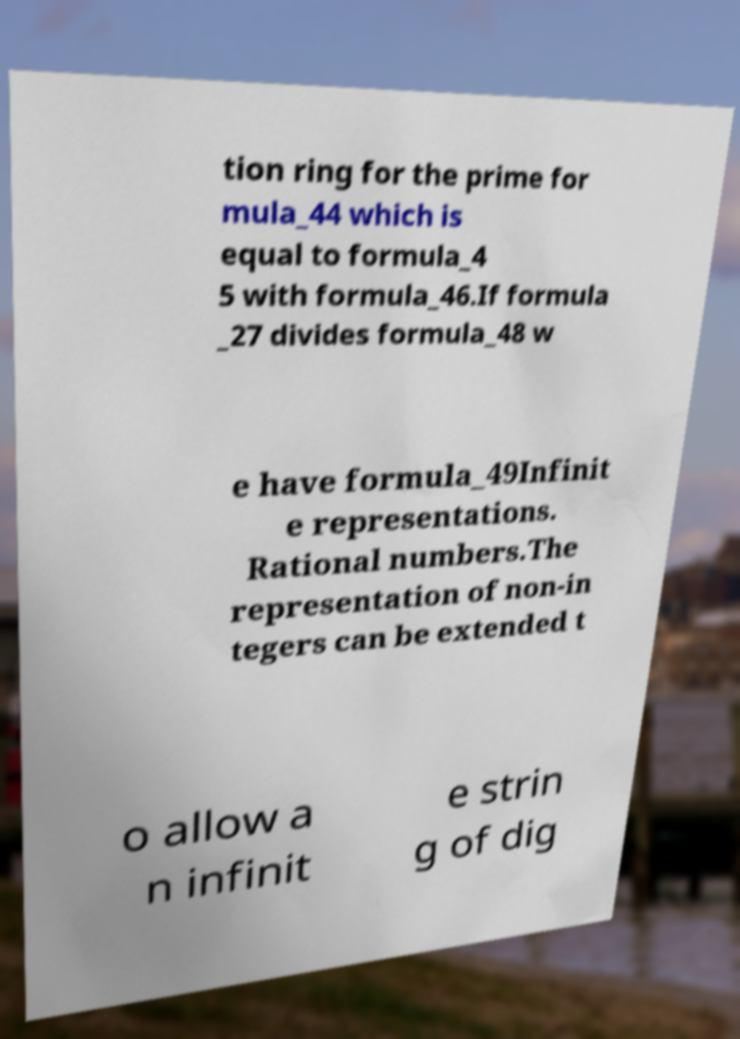Please read and relay the text visible in this image. What does it say? tion ring for the prime for mula_44 which is equal to formula_4 5 with formula_46.If formula _27 divides formula_48 w e have formula_49Infinit e representations. Rational numbers.The representation of non-in tegers can be extended t o allow a n infinit e strin g of dig 